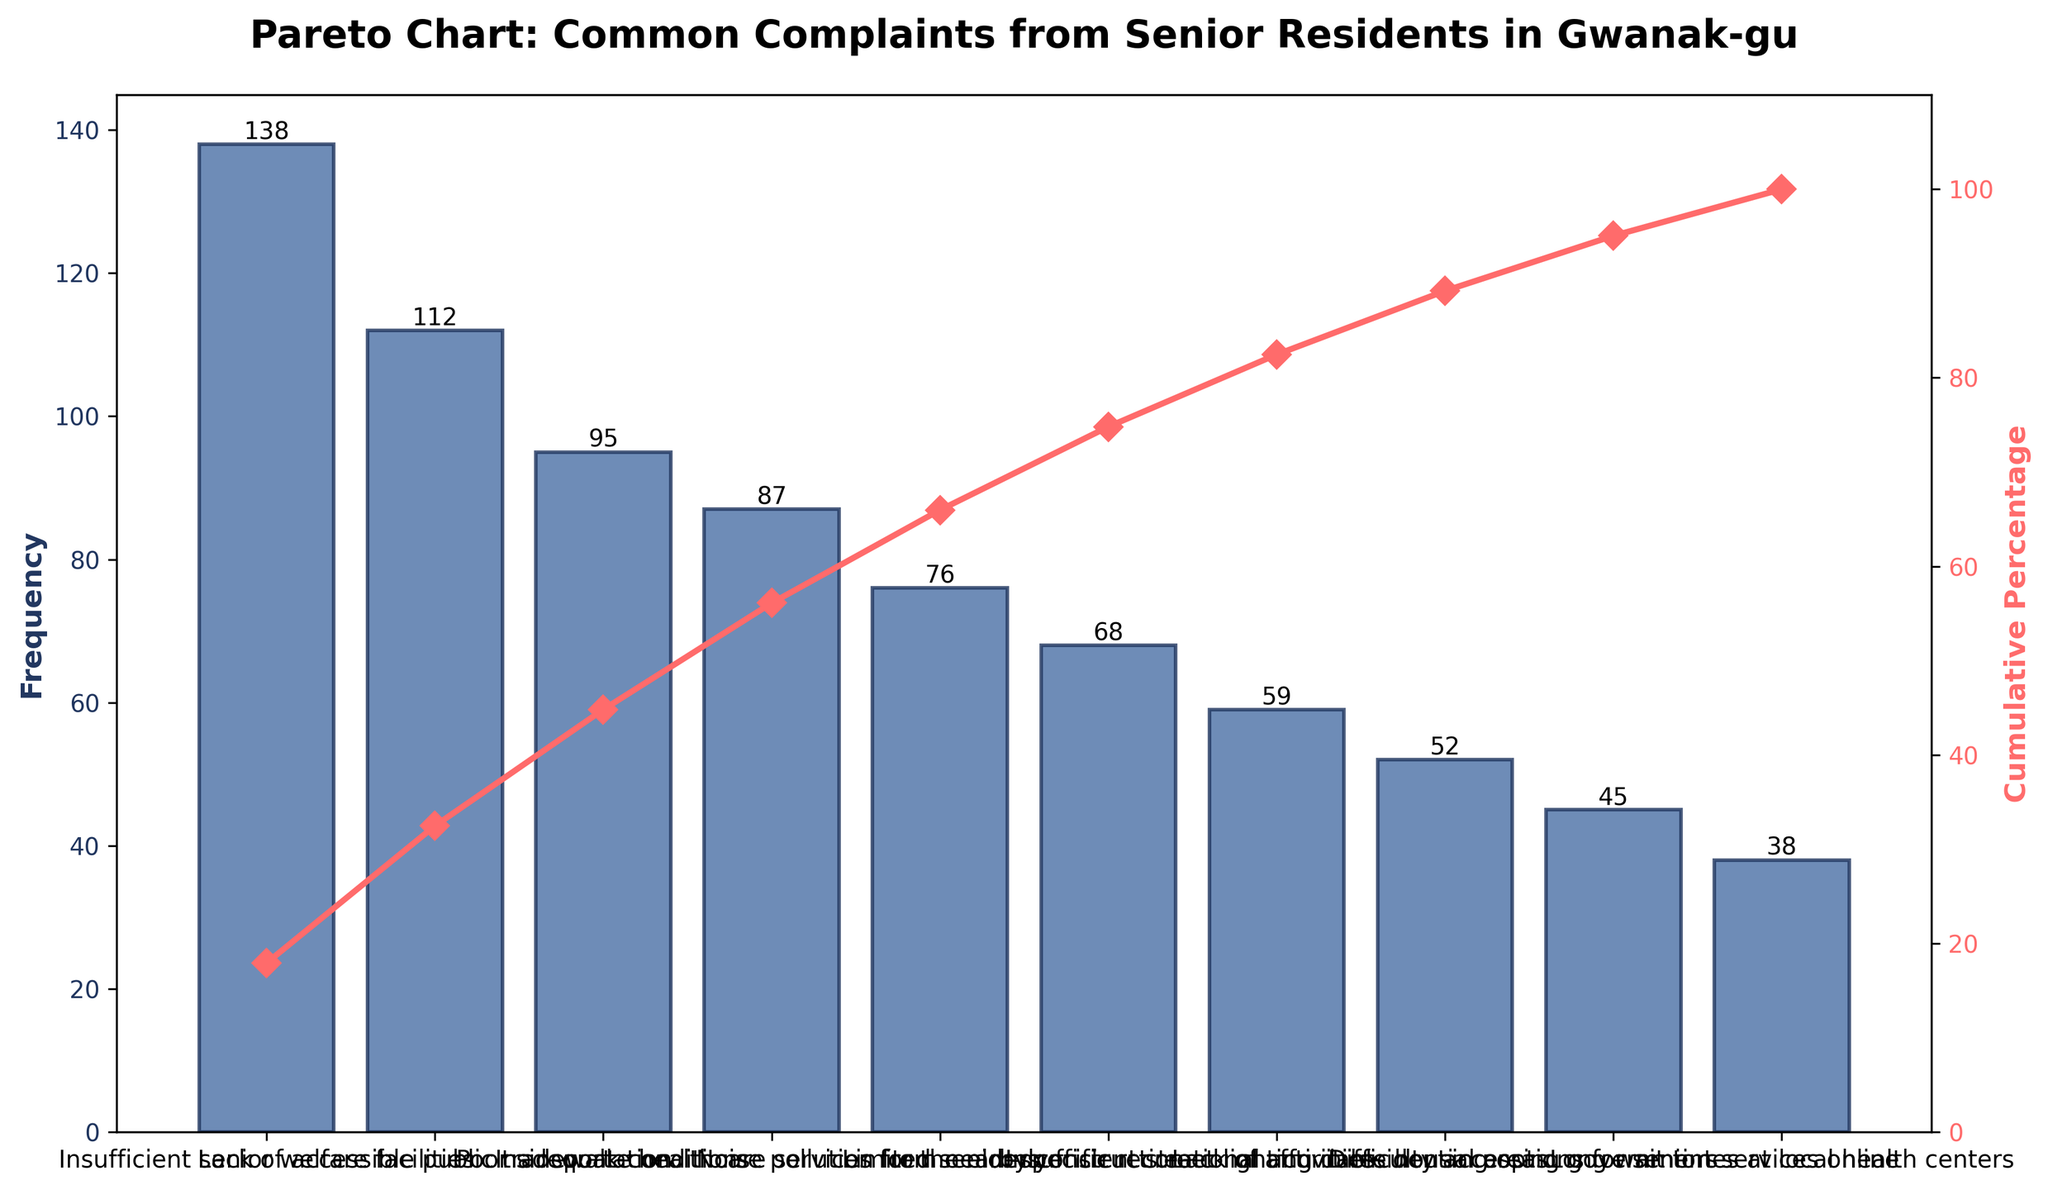What's the title of the figure? The title of the figure is usually the most prominent text at the top and summarizes the content. In this case, it's written in bold font.
Answer: Pareto Chart: Common Complaints from Senior Residents in Gwanak-gu How many complaints categories are listed? Count the number of bars in the chart, each representing a different complaint category.
Answer: 10 Which complaint has the highest frequency? Look for the tallest bar in the chart, which indicates the highest frequency.
Answer: Insufficient senior welfare facilities What's the cumulative percentage of the first three complaints? Identify the cumulative percentage values for the first three complaint categories on the right-side Y-axis. They are around 30%, 55%, and 75%. Add these percentages together.
Answer: 75% Which two complaints have the most similar frequencies? Compare the heights of all the bars and find the two bars that are closest in height.
Answer: Lack of accessible public transportation and Poor sidewalk conditions What's the frequency of "Noise pollution from nearby construction"? Look for the bar labeled "Noise pollution from nearby construction" and read the number at the top or along the Y-axis.
Answer: 76 How much higher is the frequency of "Inadequate healthcare services for the elderly" compared to "Difficulty accessing government services online"? Find the frequencies of both complaints and subtract the smaller value from the larger one: 87 for healthcare services and 45 for online services.
Answer: 42 At what cumulative percentage do the first five complaints reach? Sum the cumulative percentages of the first five complaints from the secondary Y-axis: approximately, the cumulative percentages are 30%, 55%, 75%, 90%, 100%.
Answer: 100% What is the cumulative percentage after the sixth complaint? Find the cumulative percentage after the sixth complaint from the secondary Y-axis. It's slightly above 70%.
Answer: Around 70% How many complaints have frequencies greater than 60 but less than 100? Identify the bars within the specified frequency range by checking the Y-axis values.
Answer: 3 